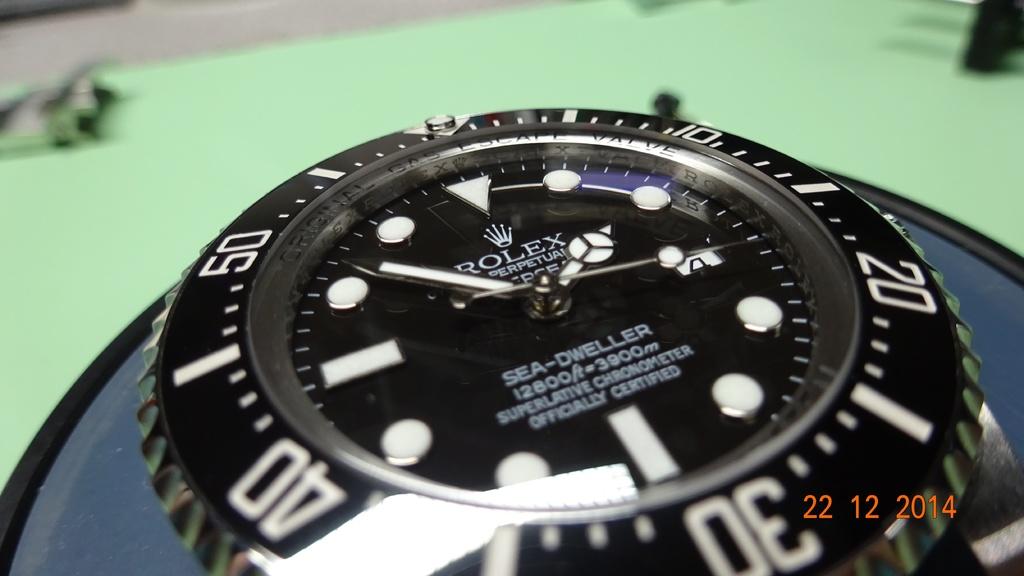What is the time the watch reads?
Make the answer very short. 1:52. What brand is this watch?
Your response must be concise. Rolex. 